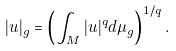<formula> <loc_0><loc_0><loc_500><loc_500>| u | _ { g } = \left ( \int _ { M } | u | ^ { q } d \mu _ { g } \right ) ^ { 1 / q } .</formula> 